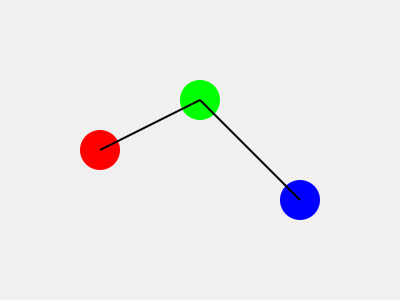In the street scene represented by the diagram, three covert operatives are marked by colored circles. If the distance between each pair of operatives is crucial for their communication, and the maximum allowed distance is 250 units, how many operative pairs can maintain direct communication? To solve this problem, we need to calculate the distances between each pair of operatives and compare them to the maximum allowed distance. Let's approach this step-by-step:

1. Identify the operatives:
   Red operative (R): (100, 150)
   Green operative (G): (200, 100)
   Blue operative (B): (300, 200)

2. Calculate the distances between each pair using the distance formula:
   $d = \sqrt{(x_2-x_1)^2 + (y_2-y_1)^2}$

   a) Distance between R and G:
      $d_{RG} = \sqrt{(200-100)^2 + (100-150)^2} = \sqrt{10000 + 2500} = \sqrt{12500} \approx 111.8$ units

   b) Distance between G and B:
      $d_{GB} = \sqrt{(300-200)^2 + (200-100)^2} = \sqrt{10000 + 10000} = \sqrt{20000} \approx 141.4$ units

   c) Distance between R and B:
      $d_{RB} = \sqrt{(300-100)^2 + (200-150)^2} = \sqrt{40000 + 2500} = \sqrt{42500} \approx 206.2$ units

3. Compare each distance to the maximum allowed distance (250 units):
   $d_{RG} \approx 111.8 < 250$
   $d_{GB} \approx 141.4 < 250$
   $d_{RB} \approx 206.2 < 250$

4. Count the number of operative pairs that can maintain direct communication:
   All three pairs (R-G, G-B, and R-B) have distances less than 250 units.

Therefore, all three operative pairs can maintain direct communication.
Answer: 3 pairs 